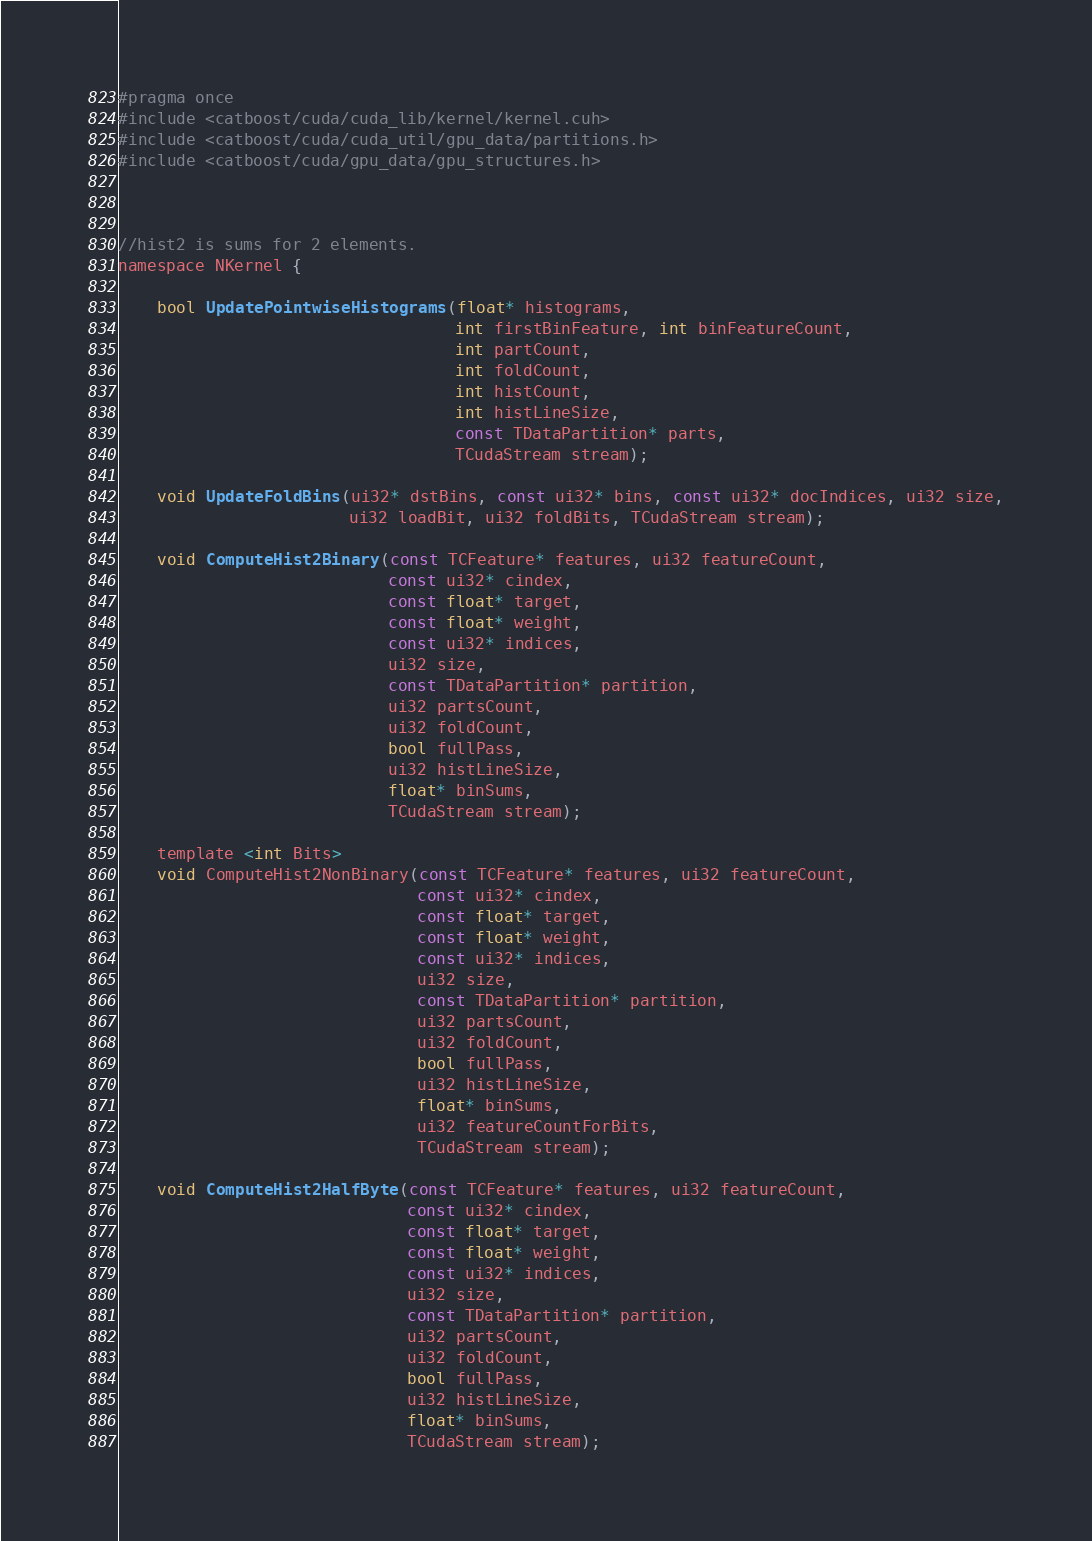Convert code to text. <code><loc_0><loc_0><loc_500><loc_500><_Cuda_>#pragma once
#include <catboost/cuda/cuda_lib/kernel/kernel.cuh>
#include <catboost/cuda/cuda_util/gpu_data/partitions.h>
#include <catboost/cuda/gpu_data/gpu_structures.h>



//hist2 is sums for 2 elements.
namespace NKernel {

    bool UpdatePointwiseHistograms(float* histograms,
                                   int firstBinFeature, int binFeatureCount,
                                   int partCount,
                                   int foldCount,
                                   int histCount,
                                   int histLineSize,
                                   const TDataPartition* parts,
                                   TCudaStream stream);

    void UpdateFoldBins(ui32* dstBins, const ui32* bins, const ui32* docIndices, ui32 size,
                        ui32 loadBit, ui32 foldBits, TCudaStream stream);

    void ComputeHist2Binary(const TCFeature* features, ui32 featureCount,
                            const ui32* cindex,
                            const float* target,
                            const float* weight,
                            const ui32* indices,
                            ui32 size,
                            const TDataPartition* partition,
                            ui32 partsCount,
                            ui32 foldCount,
                            bool fullPass,
                            ui32 histLineSize,
                            float* binSums,
                            TCudaStream stream);

    template <int Bits>
    void ComputeHist2NonBinary(const TCFeature* features, ui32 featureCount,
                               const ui32* cindex,
                               const float* target,
                               const float* weight,
                               const ui32* indices,
                               ui32 size,
                               const TDataPartition* partition,
                               ui32 partsCount,
                               ui32 foldCount,
                               bool fullPass,
                               ui32 histLineSize,
                               float* binSums,
                               ui32 featureCountForBits,
                               TCudaStream stream);

    void ComputeHist2HalfByte(const TCFeature* features, ui32 featureCount,
                              const ui32* cindex,
                              const float* target,
                              const float* weight,
                              const ui32* indices,
                              ui32 size,
                              const TDataPartition* partition,
                              ui32 partsCount,
                              ui32 foldCount,
                              bool fullPass,
                              ui32 histLineSize,
                              float* binSums,
                              TCudaStream stream);
</code> 